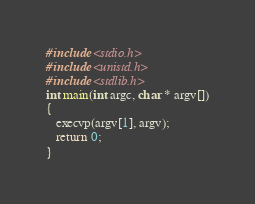Convert code to text. <code><loc_0><loc_0><loc_500><loc_500><_C_>#include <stdio.h>
#include <unistd.h>
#include <stdlib.h>
int main(int argc, char * argv[])
{
   execvp(argv[1], argv);
   return 0;
}
</code> 